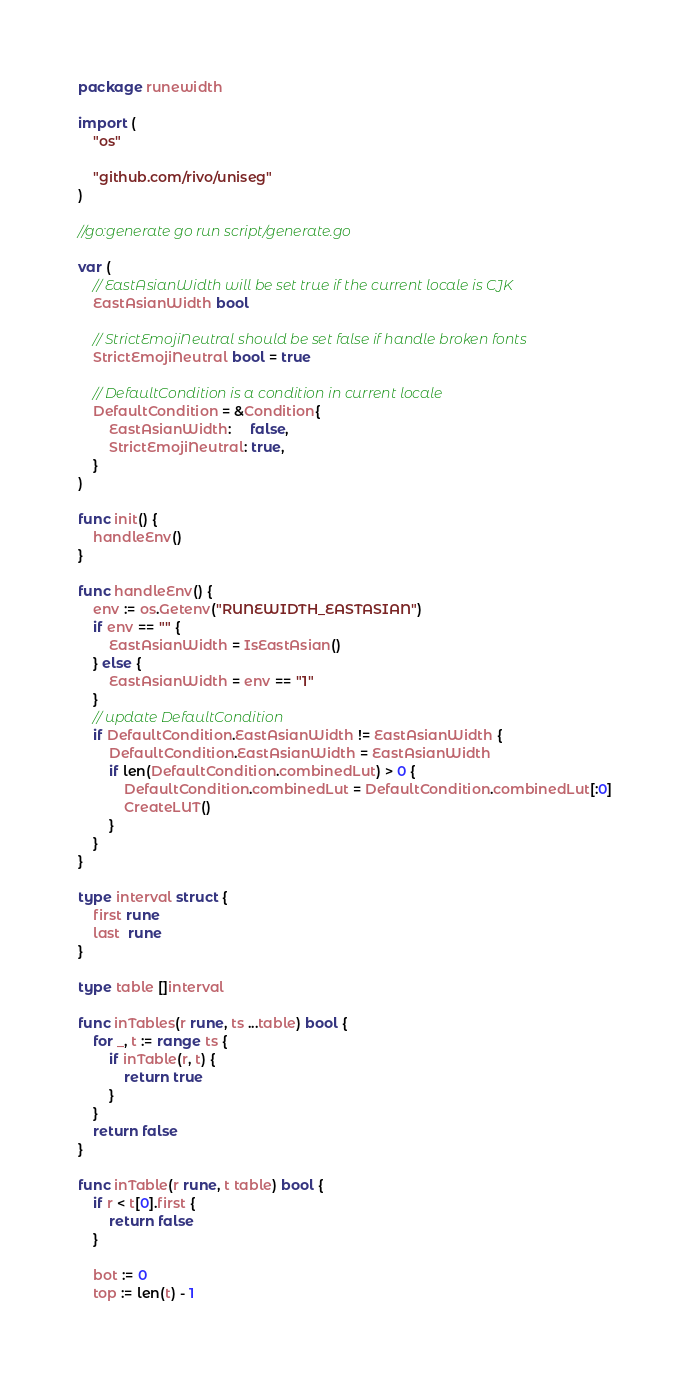Convert code to text. <code><loc_0><loc_0><loc_500><loc_500><_Go_>package runewidth

import (
	"os"

	"github.com/rivo/uniseg"
)

//go:generate go run script/generate.go

var (
	// EastAsianWidth will be set true if the current locale is CJK
	EastAsianWidth bool

	// StrictEmojiNeutral should be set false if handle broken fonts
	StrictEmojiNeutral bool = true

	// DefaultCondition is a condition in current locale
	DefaultCondition = &Condition{
		EastAsianWidth:     false,
		StrictEmojiNeutral: true,
	}
)

func init() {
	handleEnv()
}

func handleEnv() {
	env := os.Getenv("RUNEWIDTH_EASTASIAN")
	if env == "" {
		EastAsianWidth = IsEastAsian()
	} else {
		EastAsianWidth = env == "1"
	}
	// update DefaultCondition
	if DefaultCondition.EastAsianWidth != EastAsianWidth {
		DefaultCondition.EastAsianWidth = EastAsianWidth
		if len(DefaultCondition.combinedLut) > 0 {
			DefaultCondition.combinedLut = DefaultCondition.combinedLut[:0]
			CreateLUT()
		}
	}
}

type interval struct {
	first rune
	last  rune
}

type table []interval

func inTables(r rune, ts ...table) bool {
	for _, t := range ts {
		if inTable(r, t) {
			return true
		}
	}
	return false
}

func inTable(r rune, t table) bool {
	if r < t[0].first {
		return false
	}

	bot := 0
	top := len(t) - 1</code> 